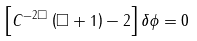<formula> <loc_0><loc_0><loc_500><loc_500>\left [ C ^ { - 2 \Box } \left ( \Box + 1 \right ) - 2 \right ] \delta \phi = 0</formula> 